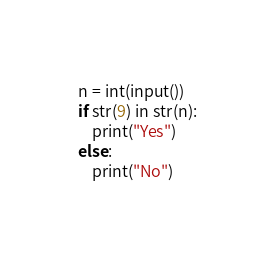<code> <loc_0><loc_0><loc_500><loc_500><_Python_>n = int(input())
if str(9) in str(n):
    print("Yes")
else:
    print("No")</code> 